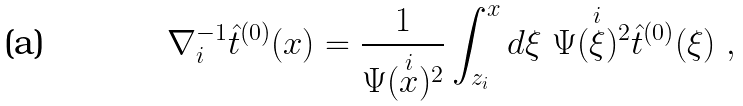<formula> <loc_0><loc_0><loc_500><loc_500>\nabla _ { i } ^ { - 1 } \hat { t } ^ { ( 0 ) } ( x ) = \frac { 1 } { \Psi ( \overset { i } { x } ) ^ { 2 } } \int _ { z _ { i } } ^ { x } d \xi \ \Psi ( \overset { i } { \xi } ) ^ { 2 } \hat { t } ^ { ( 0 ) } ( \xi ) \ ,</formula> 